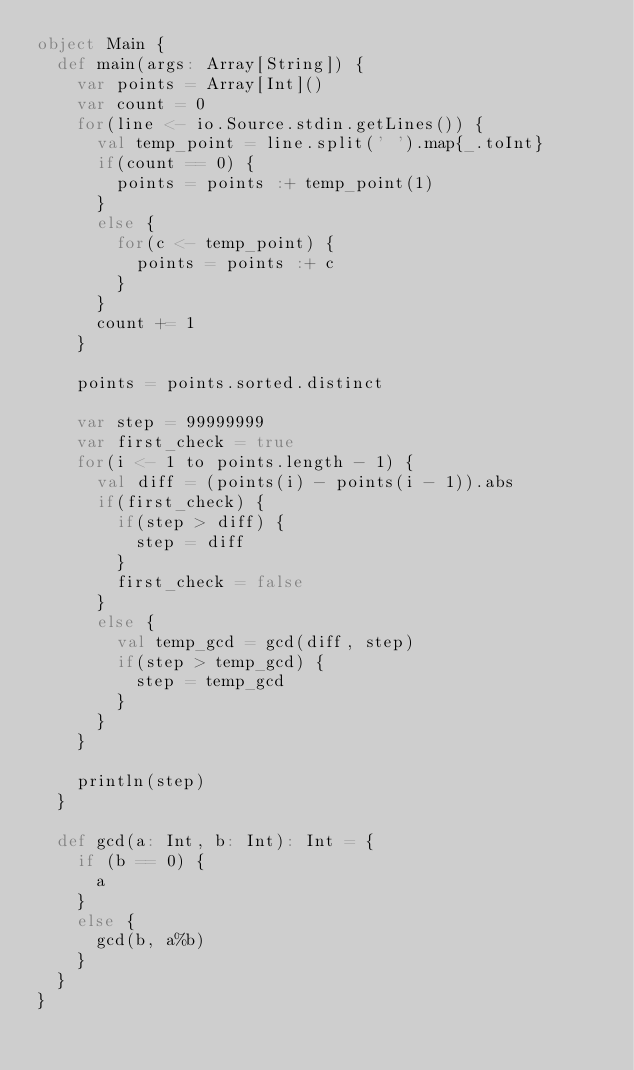Convert code to text. <code><loc_0><loc_0><loc_500><loc_500><_Scala_>object Main {
  def main(args: Array[String]) {
    var points = Array[Int]()
    var count = 0
    for(line <- io.Source.stdin.getLines()) {
      val temp_point = line.split(' ').map{_.toInt}
      if(count == 0) {
        points = points :+ temp_point(1)
      }
      else {
        for(c <- temp_point) {
          points = points :+ c
        }
      }
      count += 1
    }

    points = points.sorted.distinct
    
    var step = 99999999
    var first_check = true
    for(i <- 1 to points.length - 1) {
      val diff = (points(i) - points(i - 1)).abs
      if(first_check) {
        if(step > diff) {
          step = diff
        }
        first_check = false
      }
      else {
        val temp_gcd = gcd(diff, step)
        if(step > temp_gcd) {
          step = temp_gcd
        }
      }
    }

    println(step)
  }

  def gcd(a: Int, b: Int): Int = {
    if (b == 0) {
      a
    }
    else {
      gcd(b, a%b)
    } 
  }
}
</code> 